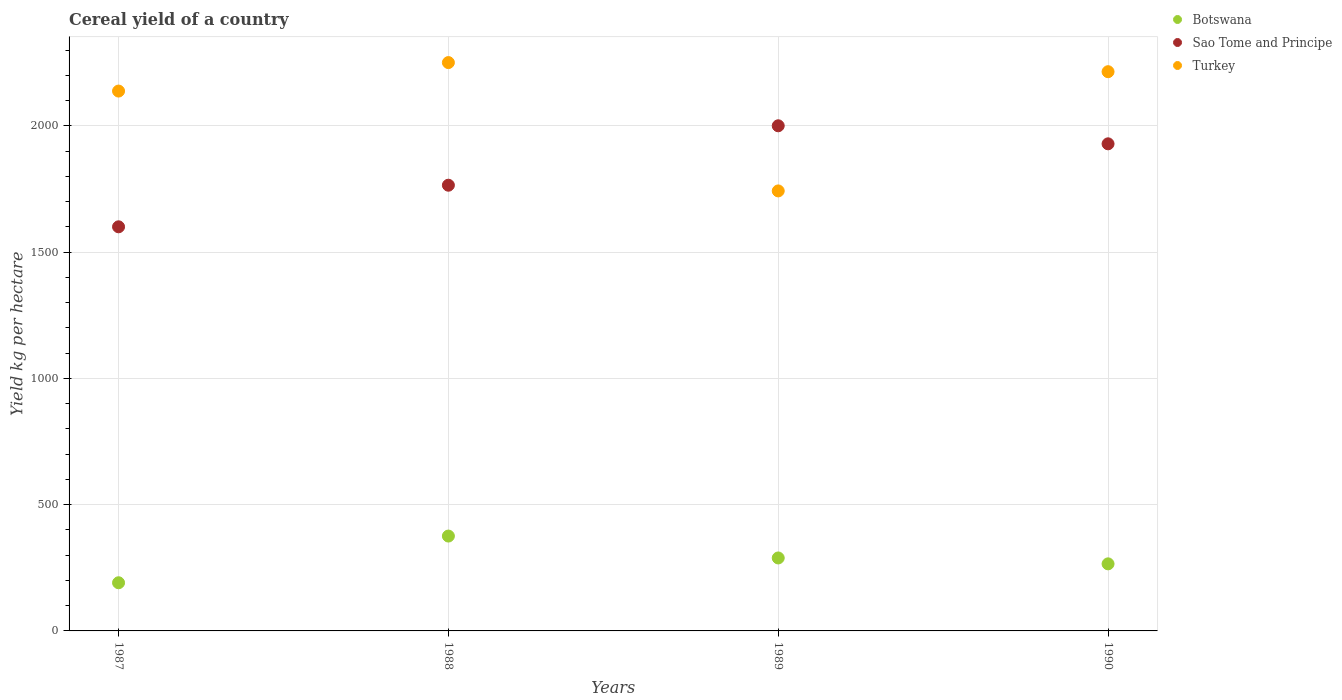How many different coloured dotlines are there?
Your answer should be compact. 3. What is the total cereal yield in Sao Tome and Principe in 1990?
Give a very brief answer. 1928.57. Across all years, what is the maximum total cereal yield in Turkey?
Offer a terse response. 2250.24. Across all years, what is the minimum total cereal yield in Turkey?
Offer a terse response. 1742.11. What is the total total cereal yield in Turkey in the graph?
Your response must be concise. 8343.94. What is the difference between the total cereal yield in Botswana in 1989 and that in 1990?
Make the answer very short. 23.34. What is the difference between the total cereal yield in Sao Tome and Principe in 1989 and the total cereal yield in Turkey in 1990?
Offer a very short reply. -214.16. What is the average total cereal yield in Turkey per year?
Offer a terse response. 2085.98. In the year 1990, what is the difference between the total cereal yield in Turkey and total cereal yield in Sao Tome and Principe?
Ensure brevity in your answer.  285.59. In how many years, is the total cereal yield in Sao Tome and Principe greater than 1800 kg per hectare?
Provide a short and direct response. 2. What is the ratio of the total cereal yield in Sao Tome and Principe in 1987 to that in 1989?
Ensure brevity in your answer.  0.8. Is the difference between the total cereal yield in Turkey in 1988 and 1989 greater than the difference between the total cereal yield in Sao Tome and Principe in 1988 and 1989?
Your answer should be compact. Yes. What is the difference between the highest and the second highest total cereal yield in Botswana?
Your answer should be very brief. 86.7. What is the difference between the highest and the lowest total cereal yield in Botswana?
Keep it short and to the point. 184.89. Is it the case that in every year, the sum of the total cereal yield in Sao Tome and Principe and total cereal yield in Botswana  is greater than the total cereal yield in Turkey?
Offer a terse response. No. Does the graph contain grids?
Your answer should be very brief. Yes. Where does the legend appear in the graph?
Ensure brevity in your answer.  Top right. How many legend labels are there?
Make the answer very short. 3. How are the legend labels stacked?
Your answer should be compact. Vertical. What is the title of the graph?
Your answer should be compact. Cereal yield of a country. Does "Suriname" appear as one of the legend labels in the graph?
Your answer should be very brief. No. What is the label or title of the Y-axis?
Offer a terse response. Yield kg per hectare. What is the Yield kg per hectare in Botswana in 1987?
Keep it short and to the point. 190.69. What is the Yield kg per hectare of Sao Tome and Principe in 1987?
Give a very brief answer. 1600. What is the Yield kg per hectare in Turkey in 1987?
Keep it short and to the point. 2137.44. What is the Yield kg per hectare in Botswana in 1988?
Provide a short and direct response. 375.58. What is the Yield kg per hectare of Sao Tome and Principe in 1988?
Your response must be concise. 1764.71. What is the Yield kg per hectare of Turkey in 1988?
Keep it short and to the point. 2250.24. What is the Yield kg per hectare in Botswana in 1989?
Your answer should be compact. 288.88. What is the Yield kg per hectare in Turkey in 1989?
Give a very brief answer. 1742.11. What is the Yield kg per hectare of Botswana in 1990?
Offer a very short reply. 265.54. What is the Yield kg per hectare of Sao Tome and Principe in 1990?
Offer a very short reply. 1928.57. What is the Yield kg per hectare of Turkey in 1990?
Your answer should be very brief. 2214.16. Across all years, what is the maximum Yield kg per hectare in Botswana?
Your response must be concise. 375.58. Across all years, what is the maximum Yield kg per hectare in Turkey?
Offer a very short reply. 2250.24. Across all years, what is the minimum Yield kg per hectare of Botswana?
Provide a short and direct response. 190.69. Across all years, what is the minimum Yield kg per hectare of Sao Tome and Principe?
Provide a succinct answer. 1600. Across all years, what is the minimum Yield kg per hectare of Turkey?
Give a very brief answer. 1742.11. What is the total Yield kg per hectare of Botswana in the graph?
Offer a very short reply. 1120.69. What is the total Yield kg per hectare of Sao Tome and Principe in the graph?
Your answer should be compact. 7293.28. What is the total Yield kg per hectare in Turkey in the graph?
Offer a very short reply. 8343.94. What is the difference between the Yield kg per hectare of Botswana in 1987 and that in 1988?
Give a very brief answer. -184.89. What is the difference between the Yield kg per hectare in Sao Tome and Principe in 1987 and that in 1988?
Ensure brevity in your answer.  -164.71. What is the difference between the Yield kg per hectare in Turkey in 1987 and that in 1988?
Your answer should be compact. -112.8. What is the difference between the Yield kg per hectare of Botswana in 1987 and that in 1989?
Ensure brevity in your answer.  -98.19. What is the difference between the Yield kg per hectare of Sao Tome and Principe in 1987 and that in 1989?
Your response must be concise. -400. What is the difference between the Yield kg per hectare of Turkey in 1987 and that in 1989?
Make the answer very short. 395.33. What is the difference between the Yield kg per hectare of Botswana in 1987 and that in 1990?
Your response must be concise. -74.84. What is the difference between the Yield kg per hectare of Sao Tome and Principe in 1987 and that in 1990?
Provide a succinct answer. -328.57. What is the difference between the Yield kg per hectare of Turkey in 1987 and that in 1990?
Make the answer very short. -76.72. What is the difference between the Yield kg per hectare in Botswana in 1988 and that in 1989?
Your answer should be very brief. 86.7. What is the difference between the Yield kg per hectare of Sao Tome and Principe in 1988 and that in 1989?
Provide a short and direct response. -235.29. What is the difference between the Yield kg per hectare of Turkey in 1988 and that in 1989?
Your answer should be compact. 508.13. What is the difference between the Yield kg per hectare of Botswana in 1988 and that in 1990?
Provide a succinct answer. 110.05. What is the difference between the Yield kg per hectare in Sao Tome and Principe in 1988 and that in 1990?
Keep it short and to the point. -163.87. What is the difference between the Yield kg per hectare of Turkey in 1988 and that in 1990?
Provide a short and direct response. 36.08. What is the difference between the Yield kg per hectare in Botswana in 1989 and that in 1990?
Make the answer very short. 23.34. What is the difference between the Yield kg per hectare in Sao Tome and Principe in 1989 and that in 1990?
Provide a succinct answer. 71.43. What is the difference between the Yield kg per hectare in Turkey in 1989 and that in 1990?
Provide a succinct answer. -472.05. What is the difference between the Yield kg per hectare in Botswana in 1987 and the Yield kg per hectare in Sao Tome and Principe in 1988?
Your answer should be compact. -1574.02. What is the difference between the Yield kg per hectare in Botswana in 1987 and the Yield kg per hectare in Turkey in 1988?
Provide a succinct answer. -2059.54. What is the difference between the Yield kg per hectare in Sao Tome and Principe in 1987 and the Yield kg per hectare in Turkey in 1988?
Provide a short and direct response. -650.24. What is the difference between the Yield kg per hectare in Botswana in 1987 and the Yield kg per hectare in Sao Tome and Principe in 1989?
Your answer should be very brief. -1809.31. What is the difference between the Yield kg per hectare in Botswana in 1987 and the Yield kg per hectare in Turkey in 1989?
Offer a very short reply. -1551.42. What is the difference between the Yield kg per hectare in Sao Tome and Principe in 1987 and the Yield kg per hectare in Turkey in 1989?
Give a very brief answer. -142.11. What is the difference between the Yield kg per hectare in Botswana in 1987 and the Yield kg per hectare in Sao Tome and Principe in 1990?
Ensure brevity in your answer.  -1737.88. What is the difference between the Yield kg per hectare in Botswana in 1987 and the Yield kg per hectare in Turkey in 1990?
Your response must be concise. -2023.47. What is the difference between the Yield kg per hectare in Sao Tome and Principe in 1987 and the Yield kg per hectare in Turkey in 1990?
Offer a very short reply. -614.16. What is the difference between the Yield kg per hectare in Botswana in 1988 and the Yield kg per hectare in Sao Tome and Principe in 1989?
Keep it short and to the point. -1624.42. What is the difference between the Yield kg per hectare of Botswana in 1988 and the Yield kg per hectare of Turkey in 1989?
Provide a short and direct response. -1366.53. What is the difference between the Yield kg per hectare of Sao Tome and Principe in 1988 and the Yield kg per hectare of Turkey in 1989?
Keep it short and to the point. 22.6. What is the difference between the Yield kg per hectare of Botswana in 1988 and the Yield kg per hectare of Sao Tome and Principe in 1990?
Offer a very short reply. -1552.99. What is the difference between the Yield kg per hectare in Botswana in 1988 and the Yield kg per hectare in Turkey in 1990?
Provide a short and direct response. -1838.58. What is the difference between the Yield kg per hectare in Sao Tome and Principe in 1988 and the Yield kg per hectare in Turkey in 1990?
Offer a terse response. -449.45. What is the difference between the Yield kg per hectare of Botswana in 1989 and the Yield kg per hectare of Sao Tome and Principe in 1990?
Provide a short and direct response. -1639.69. What is the difference between the Yield kg per hectare of Botswana in 1989 and the Yield kg per hectare of Turkey in 1990?
Offer a terse response. -1925.28. What is the difference between the Yield kg per hectare of Sao Tome and Principe in 1989 and the Yield kg per hectare of Turkey in 1990?
Offer a very short reply. -214.16. What is the average Yield kg per hectare of Botswana per year?
Your answer should be very brief. 280.17. What is the average Yield kg per hectare in Sao Tome and Principe per year?
Ensure brevity in your answer.  1823.32. What is the average Yield kg per hectare of Turkey per year?
Your answer should be very brief. 2085.98. In the year 1987, what is the difference between the Yield kg per hectare in Botswana and Yield kg per hectare in Sao Tome and Principe?
Offer a very short reply. -1409.31. In the year 1987, what is the difference between the Yield kg per hectare of Botswana and Yield kg per hectare of Turkey?
Provide a short and direct response. -1946.75. In the year 1987, what is the difference between the Yield kg per hectare in Sao Tome and Principe and Yield kg per hectare in Turkey?
Your response must be concise. -537.44. In the year 1988, what is the difference between the Yield kg per hectare in Botswana and Yield kg per hectare in Sao Tome and Principe?
Give a very brief answer. -1389.12. In the year 1988, what is the difference between the Yield kg per hectare of Botswana and Yield kg per hectare of Turkey?
Offer a very short reply. -1874.65. In the year 1988, what is the difference between the Yield kg per hectare in Sao Tome and Principe and Yield kg per hectare in Turkey?
Your answer should be very brief. -485.53. In the year 1989, what is the difference between the Yield kg per hectare in Botswana and Yield kg per hectare in Sao Tome and Principe?
Offer a terse response. -1711.12. In the year 1989, what is the difference between the Yield kg per hectare in Botswana and Yield kg per hectare in Turkey?
Your answer should be very brief. -1453.23. In the year 1989, what is the difference between the Yield kg per hectare in Sao Tome and Principe and Yield kg per hectare in Turkey?
Your answer should be compact. 257.89. In the year 1990, what is the difference between the Yield kg per hectare in Botswana and Yield kg per hectare in Sao Tome and Principe?
Your answer should be very brief. -1663.04. In the year 1990, what is the difference between the Yield kg per hectare of Botswana and Yield kg per hectare of Turkey?
Offer a very short reply. -1948.62. In the year 1990, what is the difference between the Yield kg per hectare in Sao Tome and Principe and Yield kg per hectare in Turkey?
Offer a terse response. -285.59. What is the ratio of the Yield kg per hectare in Botswana in 1987 to that in 1988?
Your response must be concise. 0.51. What is the ratio of the Yield kg per hectare of Sao Tome and Principe in 1987 to that in 1988?
Provide a succinct answer. 0.91. What is the ratio of the Yield kg per hectare in Turkey in 1987 to that in 1988?
Provide a succinct answer. 0.95. What is the ratio of the Yield kg per hectare in Botswana in 1987 to that in 1989?
Your answer should be very brief. 0.66. What is the ratio of the Yield kg per hectare in Turkey in 1987 to that in 1989?
Provide a succinct answer. 1.23. What is the ratio of the Yield kg per hectare of Botswana in 1987 to that in 1990?
Offer a terse response. 0.72. What is the ratio of the Yield kg per hectare in Sao Tome and Principe in 1987 to that in 1990?
Make the answer very short. 0.83. What is the ratio of the Yield kg per hectare of Turkey in 1987 to that in 1990?
Ensure brevity in your answer.  0.97. What is the ratio of the Yield kg per hectare in Botswana in 1988 to that in 1989?
Offer a terse response. 1.3. What is the ratio of the Yield kg per hectare of Sao Tome and Principe in 1988 to that in 1989?
Your answer should be compact. 0.88. What is the ratio of the Yield kg per hectare in Turkey in 1988 to that in 1989?
Provide a succinct answer. 1.29. What is the ratio of the Yield kg per hectare of Botswana in 1988 to that in 1990?
Your response must be concise. 1.41. What is the ratio of the Yield kg per hectare of Sao Tome and Principe in 1988 to that in 1990?
Give a very brief answer. 0.92. What is the ratio of the Yield kg per hectare in Turkey in 1988 to that in 1990?
Give a very brief answer. 1.02. What is the ratio of the Yield kg per hectare in Botswana in 1989 to that in 1990?
Provide a succinct answer. 1.09. What is the ratio of the Yield kg per hectare of Turkey in 1989 to that in 1990?
Your answer should be very brief. 0.79. What is the difference between the highest and the second highest Yield kg per hectare in Botswana?
Your answer should be very brief. 86.7. What is the difference between the highest and the second highest Yield kg per hectare in Sao Tome and Principe?
Provide a succinct answer. 71.43. What is the difference between the highest and the second highest Yield kg per hectare in Turkey?
Keep it short and to the point. 36.08. What is the difference between the highest and the lowest Yield kg per hectare of Botswana?
Your answer should be compact. 184.89. What is the difference between the highest and the lowest Yield kg per hectare in Sao Tome and Principe?
Offer a terse response. 400. What is the difference between the highest and the lowest Yield kg per hectare of Turkey?
Provide a succinct answer. 508.13. 